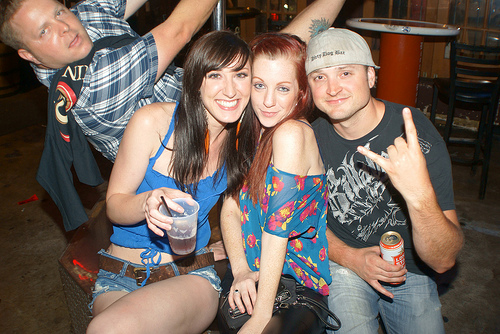<image>
Is the cup on the girl? Yes. Looking at the image, I can see the cup is positioned on top of the girl, with the girl providing support. Where is the man in relation to the woman? Is it to the left of the woman? No. The man is not to the left of the woman. From this viewpoint, they have a different horizontal relationship. 